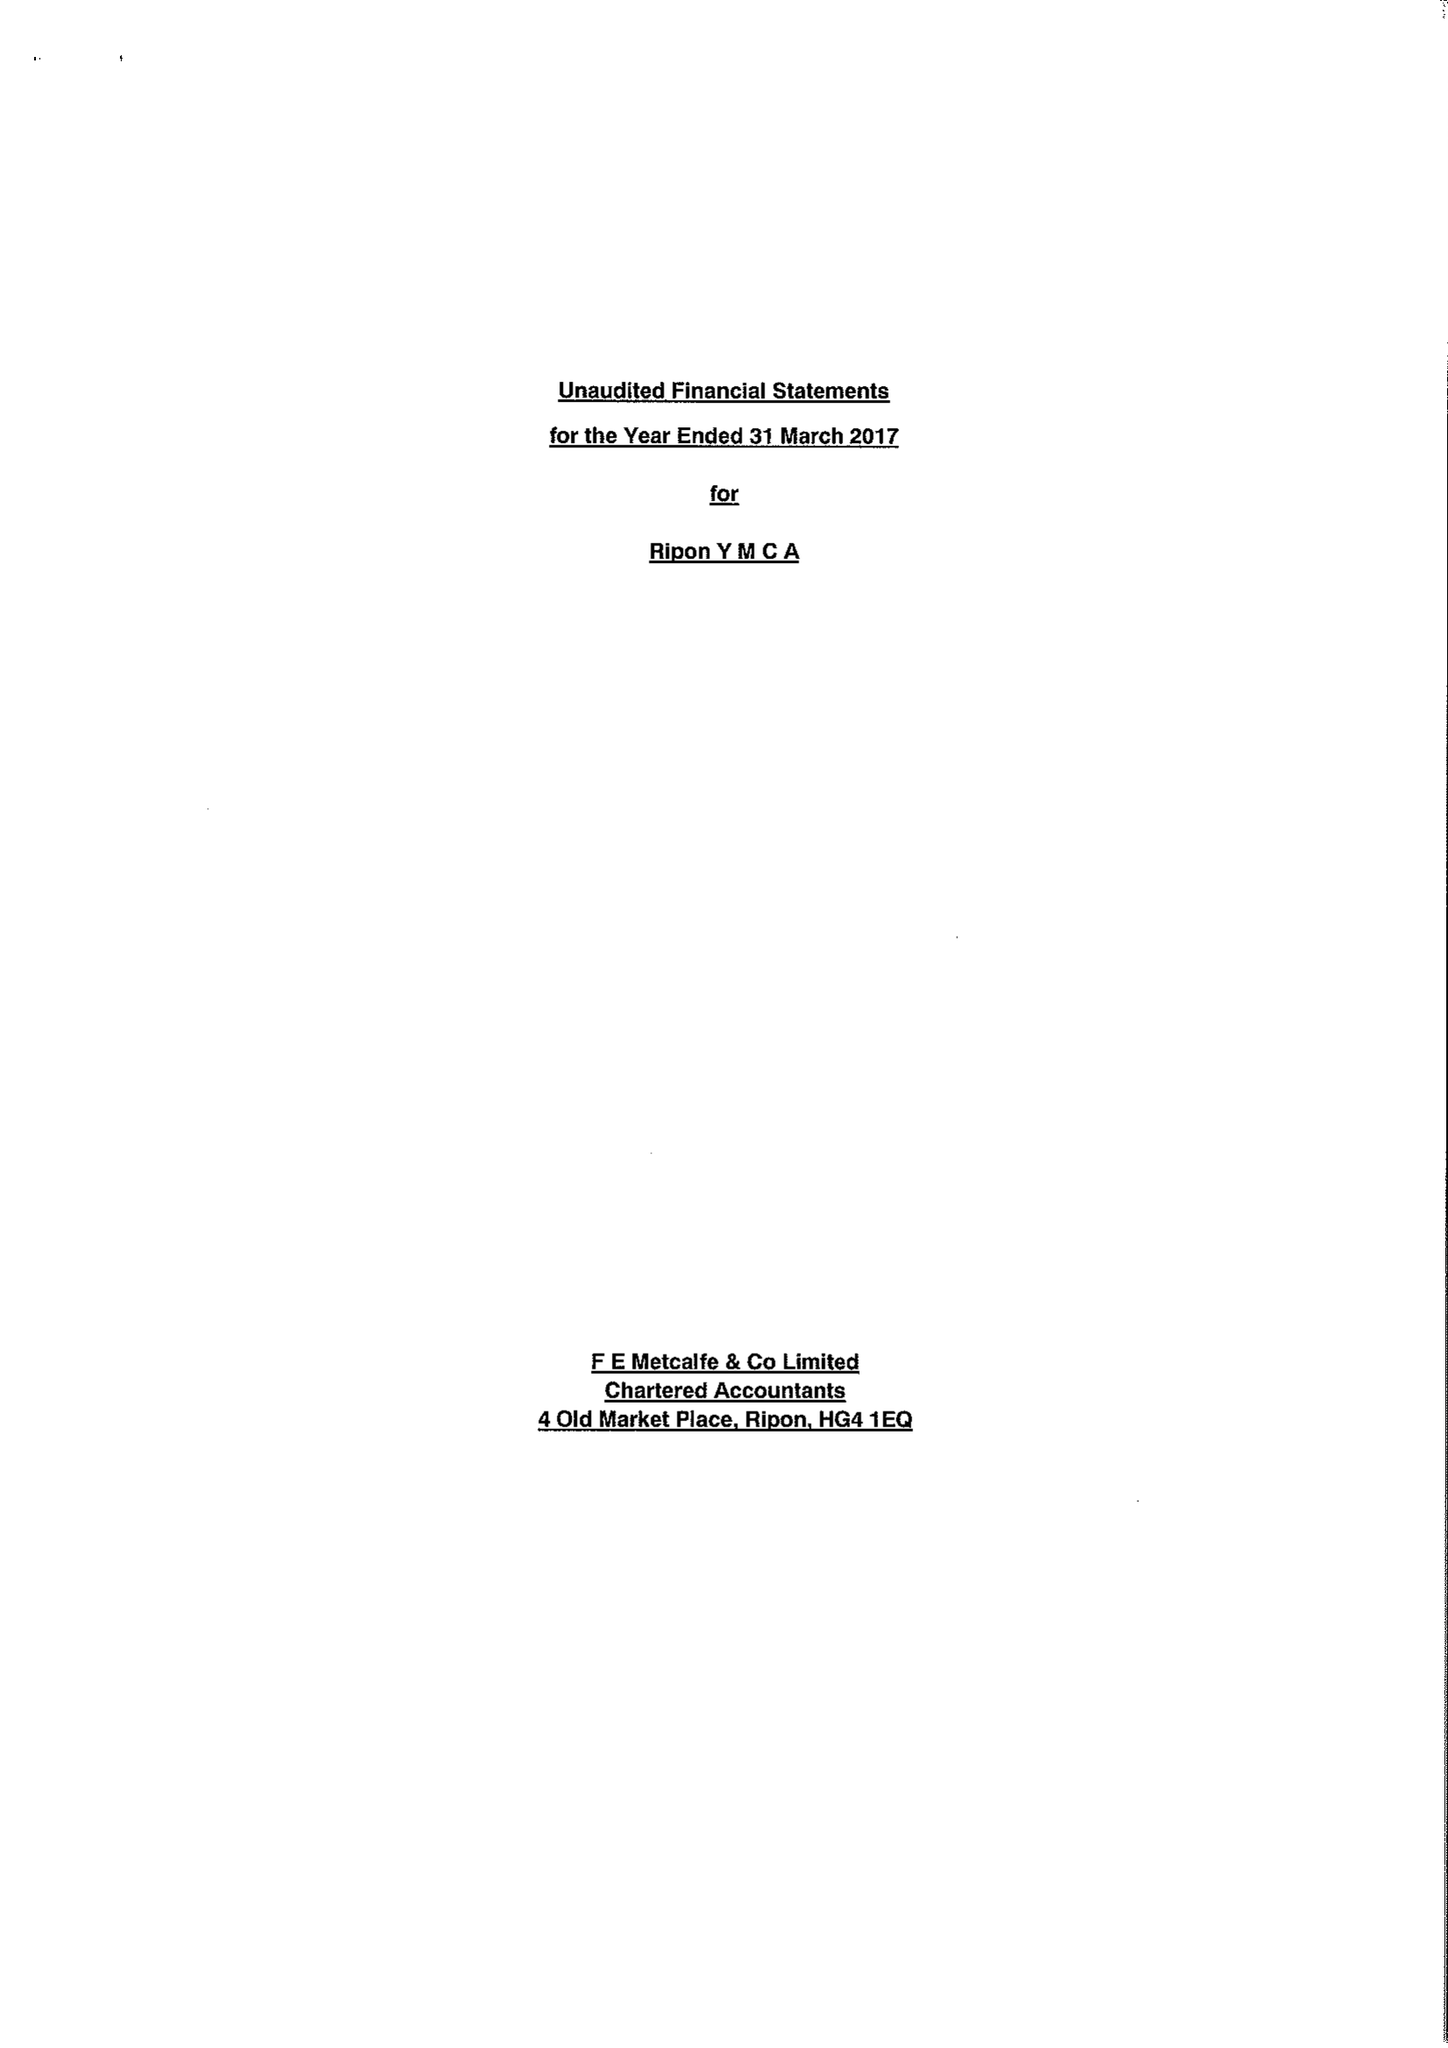What is the value for the spending_annually_in_british_pounds?
Answer the question using a single word or phrase. 159930.00 